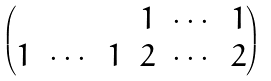Convert formula to latex. <formula><loc_0><loc_0><loc_500><loc_500>\begin{pmatrix} & & & 1 & \cdots & 1 \\ 1 & \cdots & 1 & 2 & \cdots & 2 \end{pmatrix}</formula> 